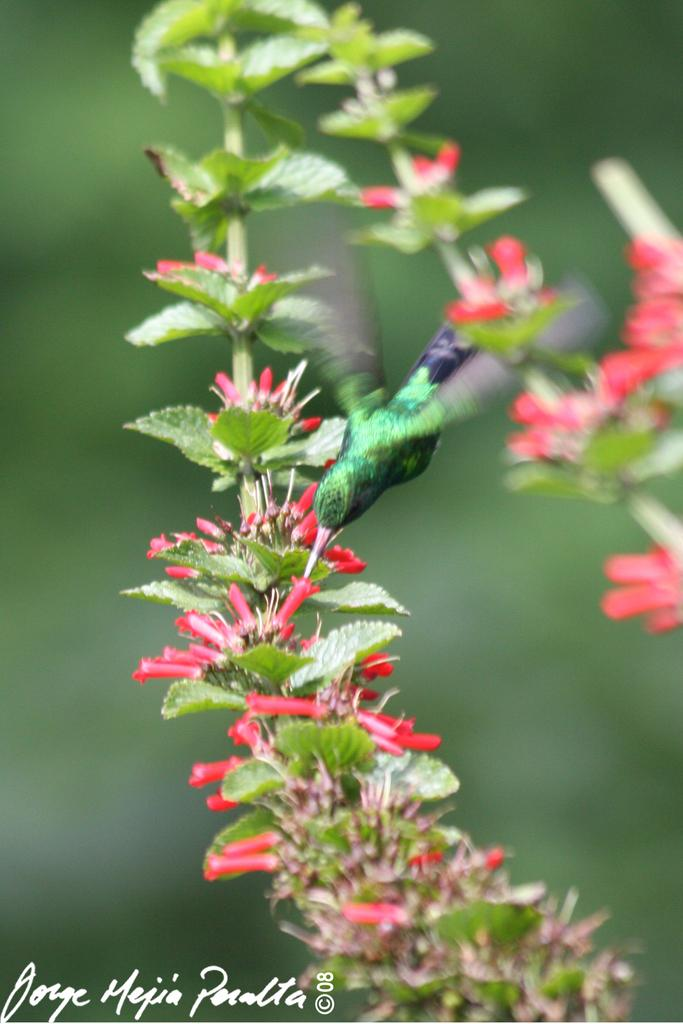What type of bird can be seen in the image? There is a small green bird in the image. Where is the bird located in the image? The bird is sitting on a red flower plant. Can you describe the background of the image? The background of the image is blurred. What reason does the bird have for playing with the destruction of the flower plant in the image? There is no indication in the image that the bird is playing or causing destruction to the flower plant. 